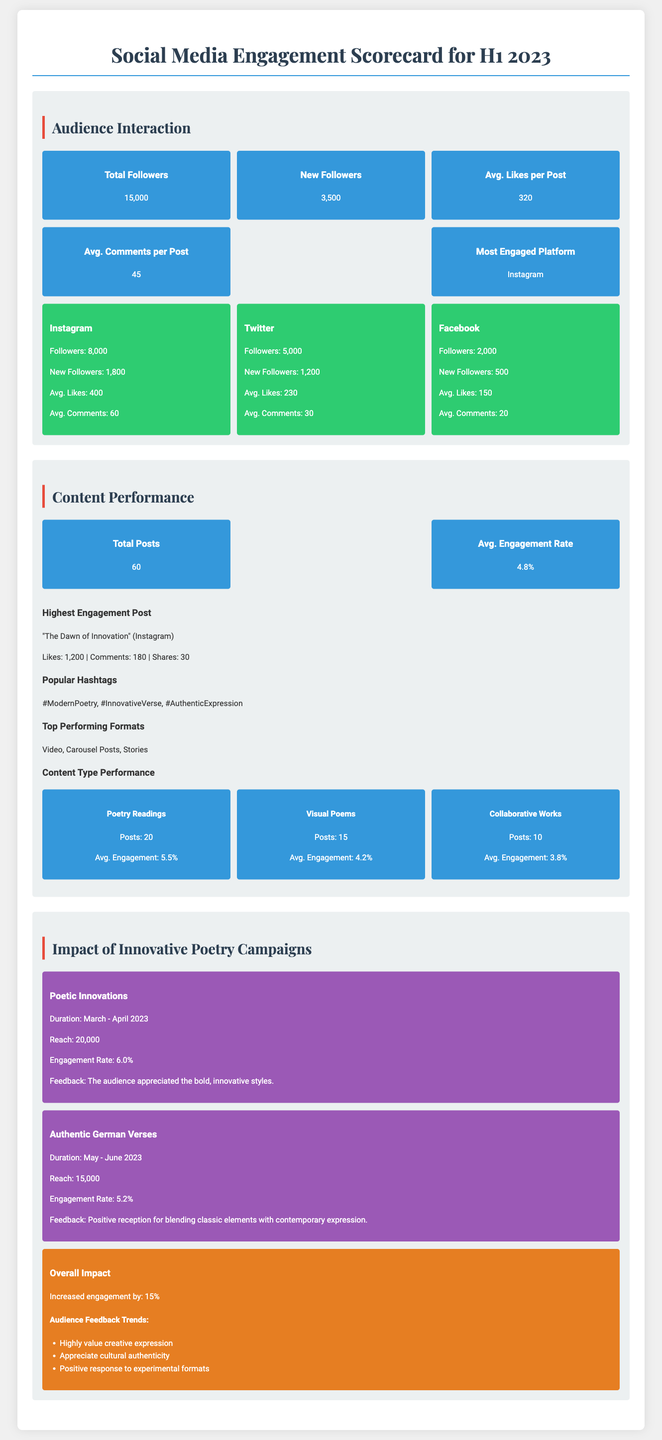What is the total number of followers? The total number of followers is stated in the Audience Interaction section of the document.
Answer: 15,000 Which platform had the most new followers? This information can be found under the platform stats within the Audience Interaction section.
Answer: Instagram What was the average engagement rate for content performance? The average engagement rate is highlighted in the Content Performance section.
Answer: 4.8% What was the reach of the "Poetic Innovations" campaign? This detail is provided in the Impact of Innovative Poetry Campaigns section of the document.
Answer: 20,000 How many poetry readings were posted? The number of posts related to poetry readings is found in the Content Type Performance subsection.
Answer: 20 What was the engagement rate for the "Authentic German Verses" campaign? This rate is mentioned in the Impact of Innovative Poetry Campaigns section, detailing the performance of that campaign.
Answer: 5.2% Which content type had the highest average engagement? The content type with the highest engagement is listed in the Content Type Performance section, comparing different formats.
Answer: Poetry Readings What feedback did audiences provide for poetic innovations? The audience's feedback is included in the description of the "Poetic Innovations" campaign.
Answer: The audience appreciated the bold, innovative styles What was the overall impact on engagement? This metric is noted in the Overall Impact subsection under the Impact of Innovative Poetry Campaigns.
Answer: Increased engagement by: 15% 